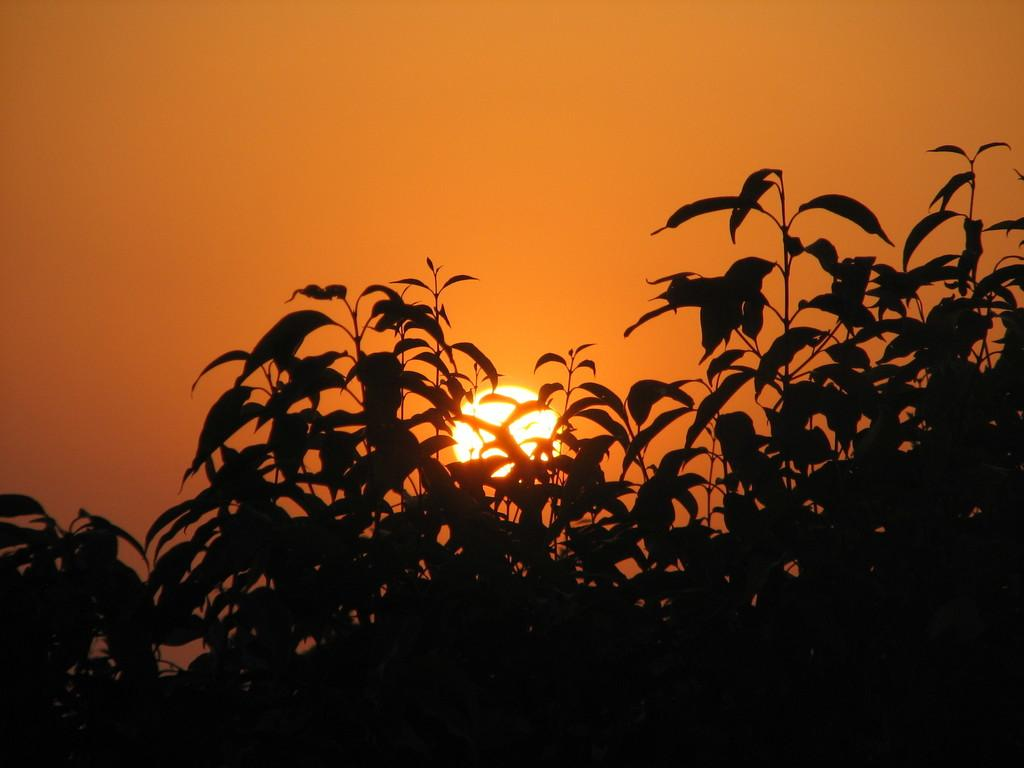What celestial body is visible in the image? There is a sun in the image. What type of vegetation can be seen in the image? There are trees in the image. What part of the natural environment is visible in the image? The sky is visible in the image. How many sticks are arranged in a vase in the image? There is no vase or sticks present in the image. 